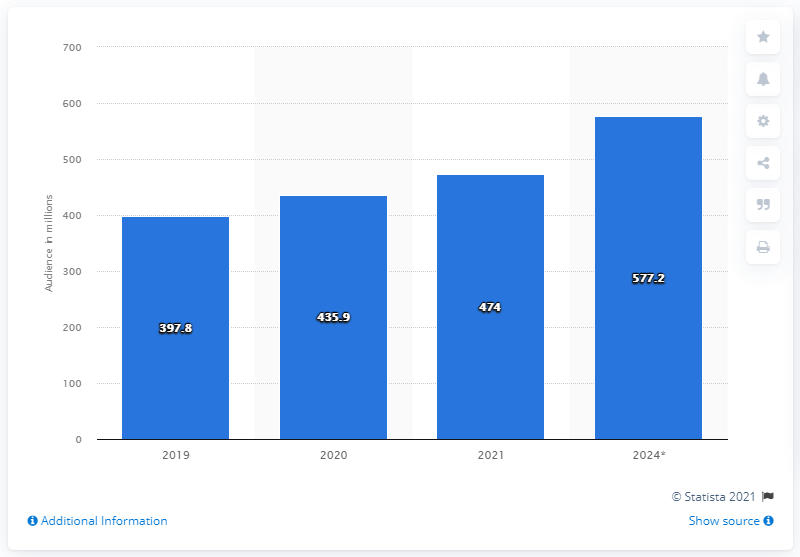Draw attention to some important aspects in this diagram. In 2019, it is estimated that 397.8 million people watched eSports. By 2024, it is expected that a significant number of people will watch eSports. Specifically, it is projected that 577.2 people will engage in eSports viewing. 